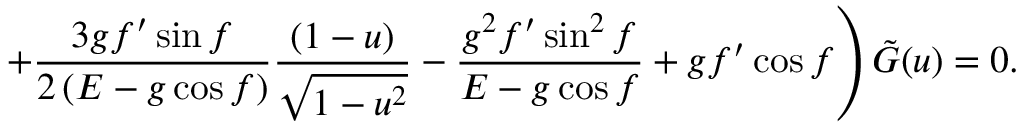Convert formula to latex. <formula><loc_0><loc_0><loc_500><loc_500>+ \frac { 3 g f ^ { \prime } \sin f } { 2 \left ( E - g \cos f \right ) } \frac { ( 1 - u ) } { \sqrt { 1 - u ^ { 2 } } } - \frac { g ^ { 2 } f ^ { \prime } \sin ^ { 2 } f } { E - g \cos f } + g f ^ { \prime } \cos f \right ) { \tilde { G } } ( u ) = 0 .</formula> 